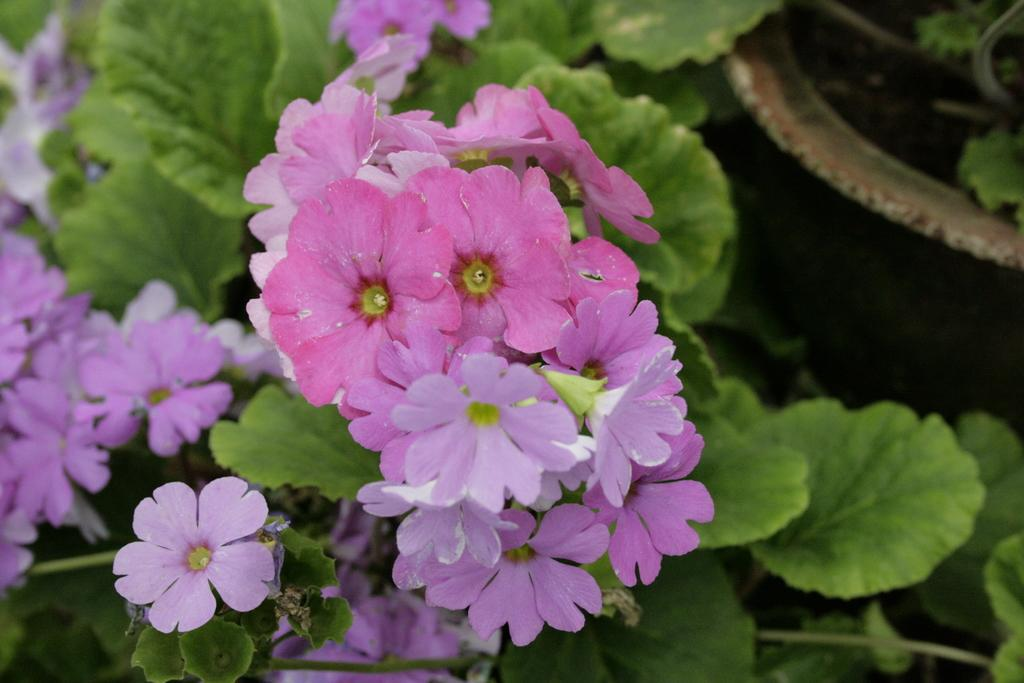What type of plant life is visible in the image? There are many flowers, green leaves, and stems in the image. Can you describe the colors of the flowers in the image? The colors of the flowers in the image are not specified, but they are likely to be vibrant and diverse. What is located on the right side of the image? There is an object on the right side of the image, but its nature is not specified. Can you tell me how many mint leaves are in the image? There is no mention of mint leaves in the image, so it is not possible to determine their number. 